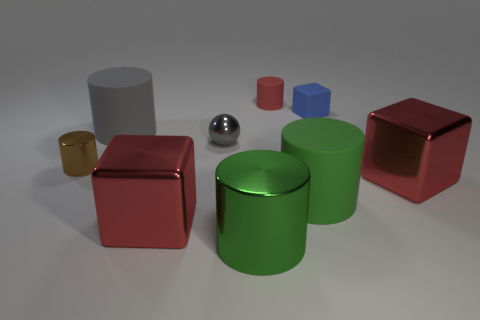Do the tiny metal ball and the big matte cylinder that is behind the small metal cylinder have the same color?
Ensure brevity in your answer.  Yes. What material is the cube that is the same size as the red matte object?
Give a very brief answer. Rubber. Is the number of big red shiny blocks behind the large green metallic thing less than the number of metallic things that are on the left side of the small blue cube?
Your answer should be compact. Yes. There is a big red shiny thing in front of the red shiny thing that is to the right of the rubber cube; what is its shape?
Offer a terse response. Cube. Are there any shiny balls?
Give a very brief answer. Yes. There is a metallic object behind the small brown thing; what color is it?
Your answer should be very brief. Gray. There is a brown thing; are there any cubes behind it?
Your response must be concise. Yes. Is the number of small metallic balls greater than the number of tiny yellow matte things?
Your response must be concise. Yes. There is a metal thing that is behind the tiny thing on the left side of the big red thing on the left side of the red cylinder; what color is it?
Keep it short and to the point. Gray. There is a small cube that is made of the same material as the large gray cylinder; what is its color?
Provide a short and direct response. Blue. 